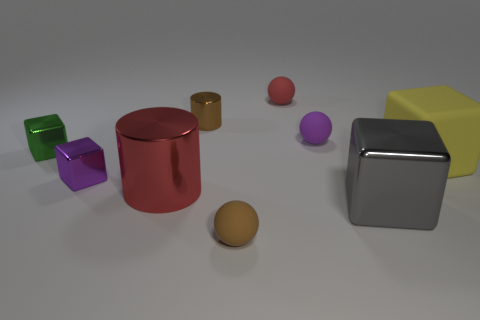How many other things are the same material as the red ball?
Your answer should be very brief. 3. How many small objects are either purple shiny cubes or blue cubes?
Keep it short and to the point. 1. Are the tiny cylinder and the green object made of the same material?
Your response must be concise. Yes. There is a small purple thing that is in front of the small green object; what number of large metallic objects are on the right side of it?
Your answer should be very brief. 2. Is there a big green thing of the same shape as the large yellow object?
Make the answer very short. No. There is a small brown object that is behind the yellow matte thing; is it the same shape as the red thing that is on the left side of the small brown matte sphere?
Ensure brevity in your answer.  Yes. There is a object that is both left of the small red ball and right of the brown shiny object; what is its shape?
Offer a very short reply. Sphere. Is there a cylinder that has the same size as the green object?
Ensure brevity in your answer.  Yes. Is the color of the small metal cylinder the same as the matte ball that is behind the small cylinder?
Your answer should be very brief. No. What material is the large red cylinder?
Offer a terse response. Metal. 